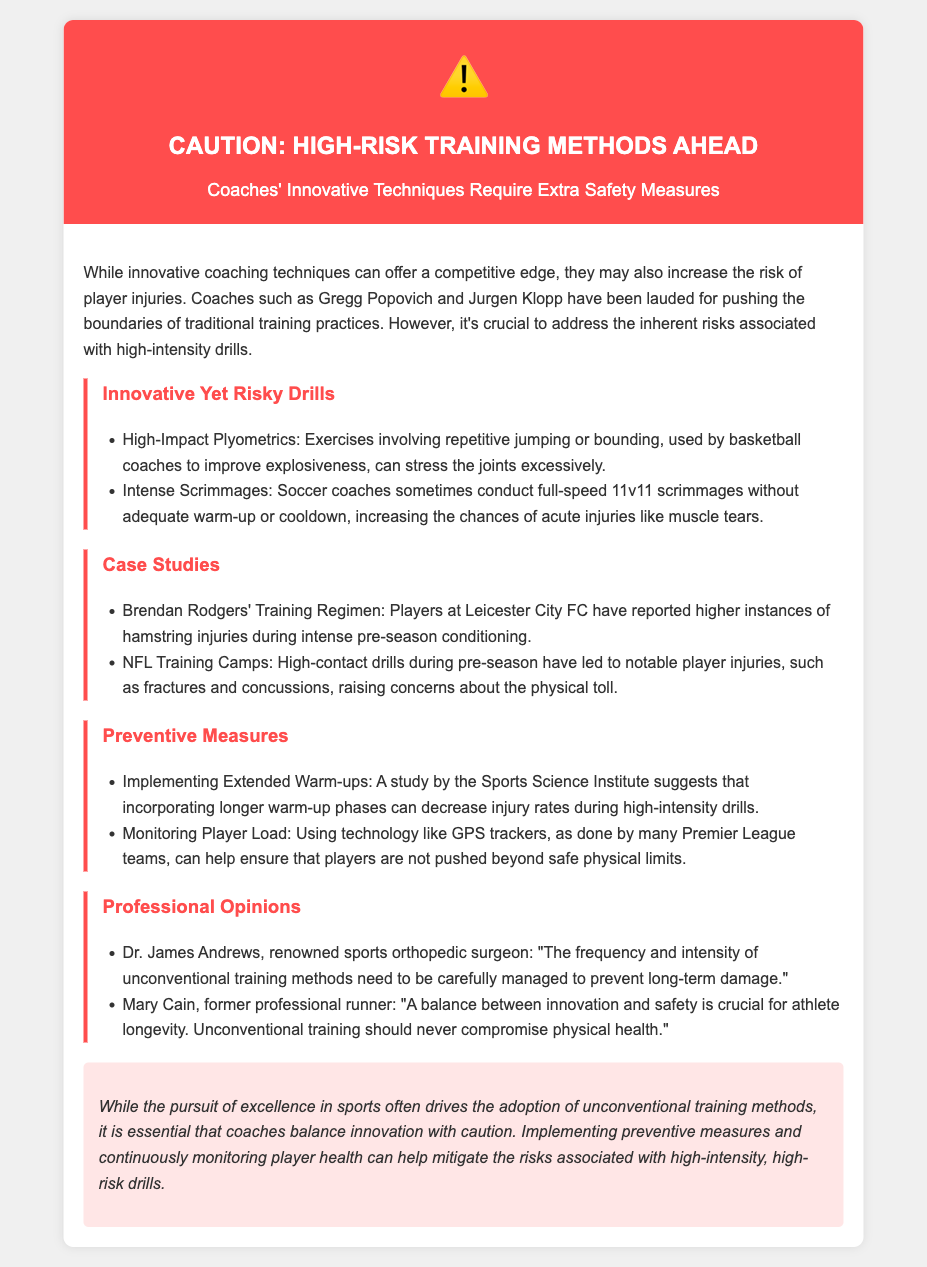what is the title of the document? The title of the document as given in the header is "Warning: Unconventional Training Sessions".
Answer: Warning: Unconventional Training Sessions who is a renowned sports orthopedic surgeon mentioned in the document? The document references Dr. James Andrews as a renowned sports orthopedic surgeon.
Answer: Dr. James Andrews what type of drills are described as high-risk in the document? The document specifically mentions "High-Impact Plyometrics" and "Intense Scrimmages" as high-risk drills.
Answer: High-Impact Plyometrics, Intense Scrimmages name one preventive measure suggested in the document. One preventive measure mentioned is "Implementing Extended Warm-ups".
Answer: Implementing Extended Warm-ups what did Mary Cain emphasize in her opinion? Mary Cain emphasized the importance of a balance between innovation and safety in athlete training.
Answer: Innovation and safety balance how can technology aid in player safety according to the document? The document states that using technology like GPS trackers can help monitor player load and ensure safety.
Answer: GPS trackers which coach's training regimen is highlighted for its injury risk? The training regimen of Brendan Rodgers at Leicester City FC is highlighted for increased hamstring injuries.
Answer: Brendan Rodgers how does the document characterize the relationship between coaching methods and injury risk? The document emphasizes that innovative coaching techniques carry an increased risk of player injuries.
Answer: Increased risk of player injuries 